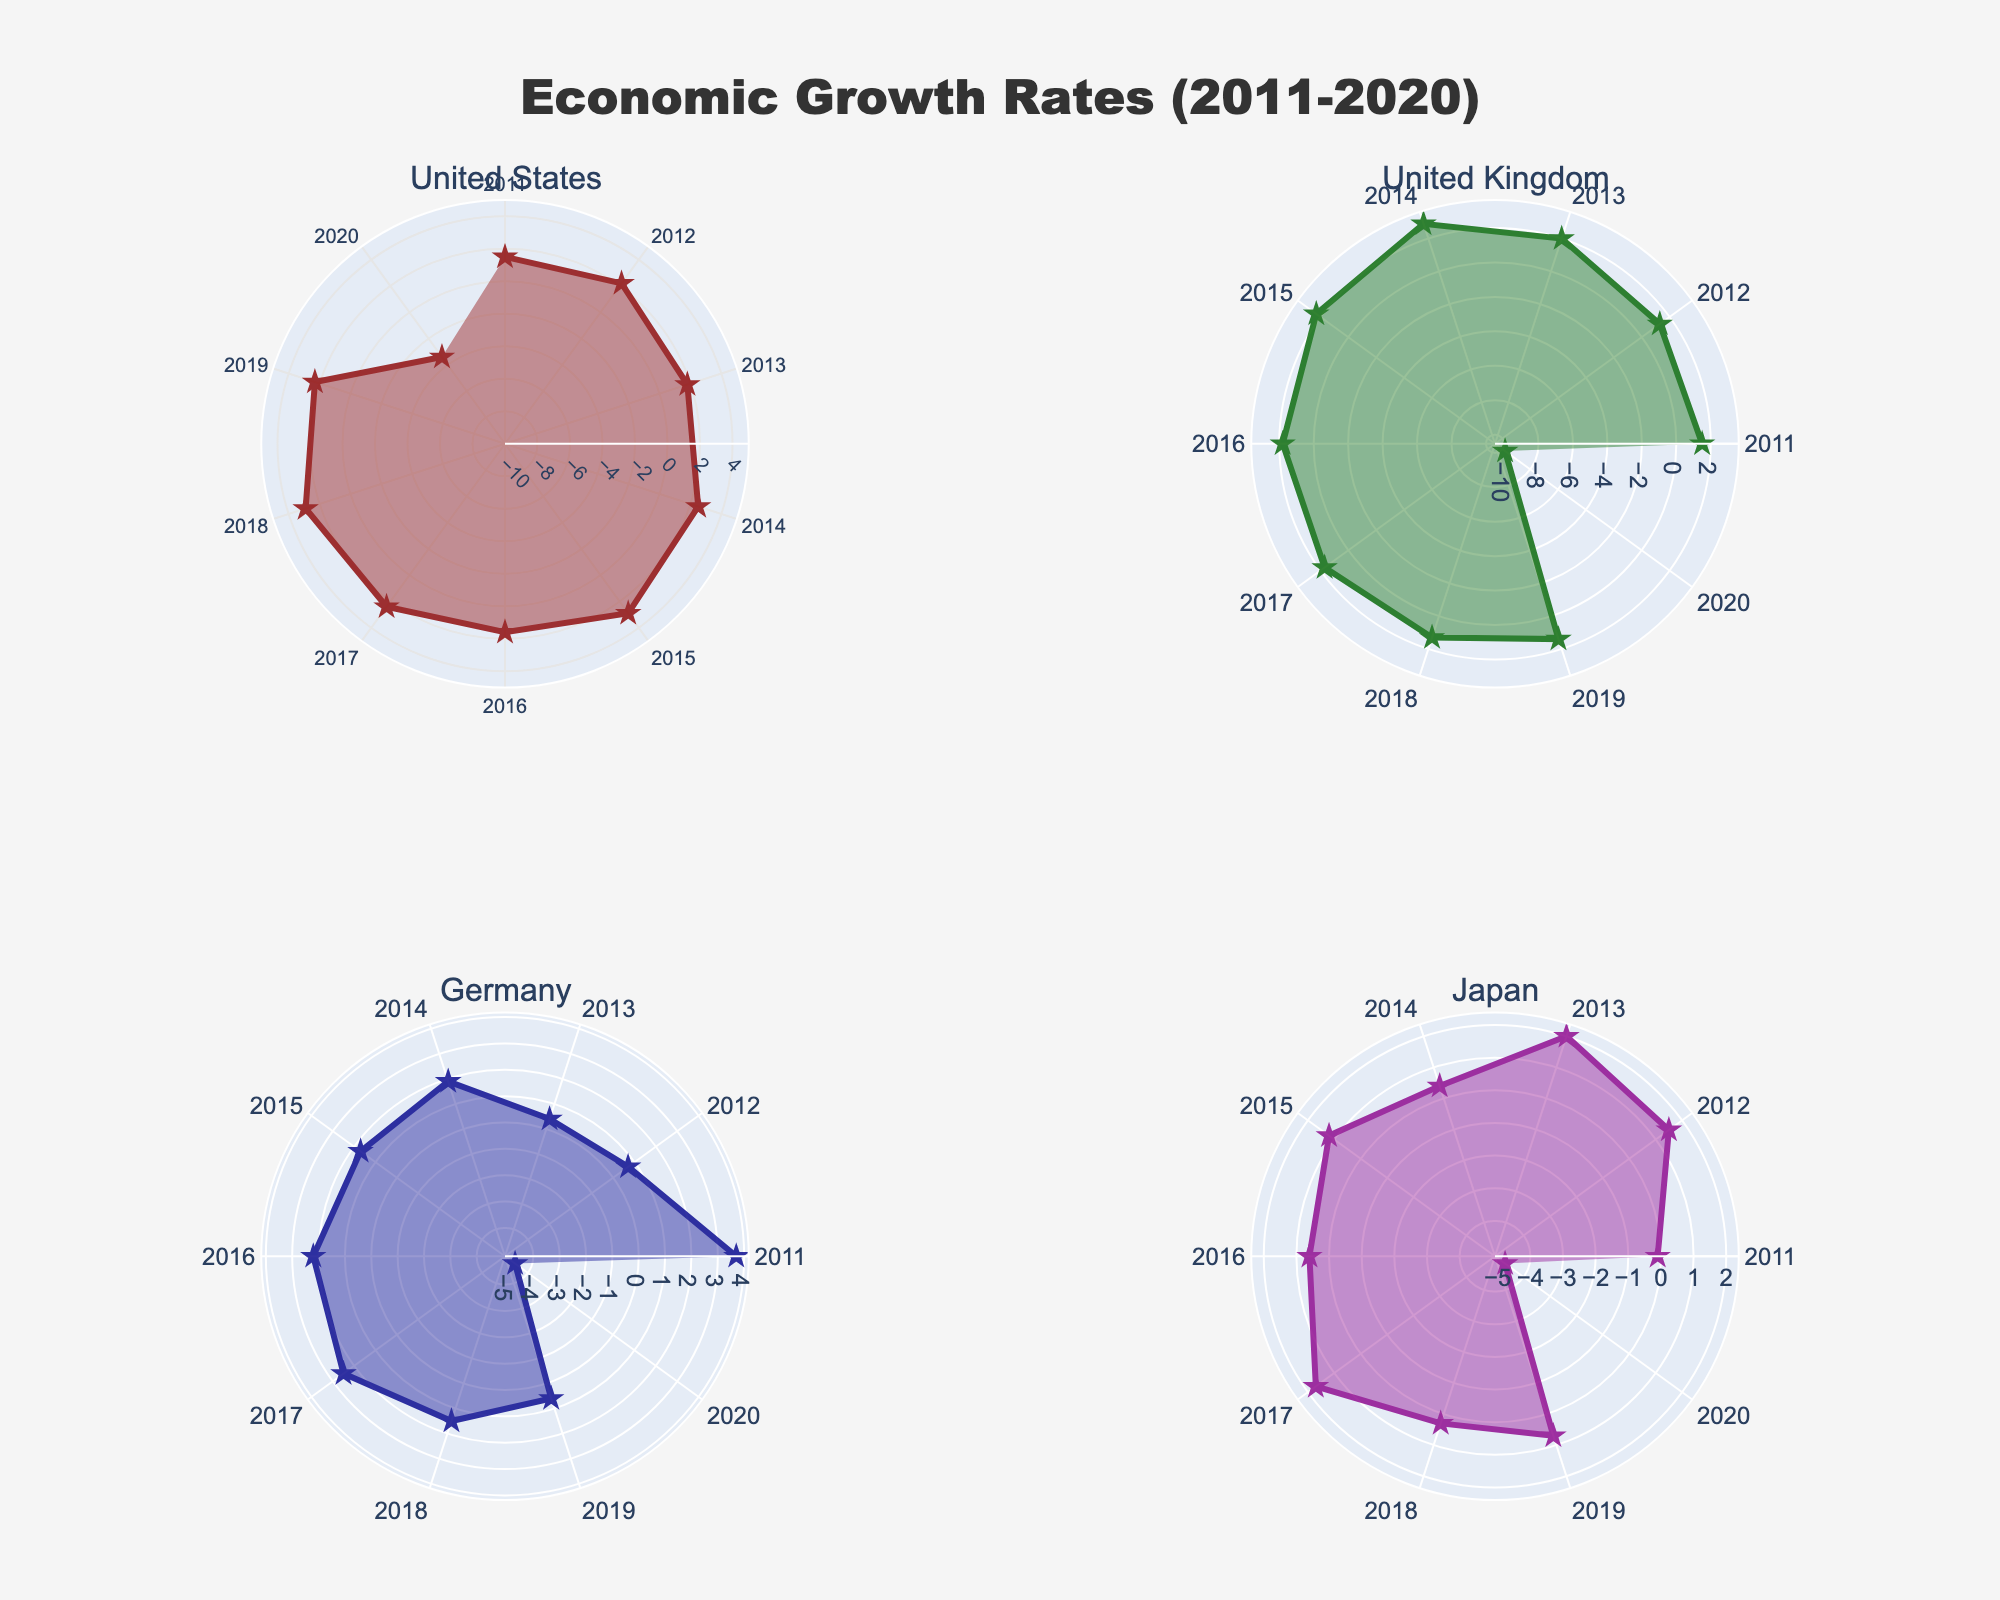What is the title of the figure? The title is prominently displayed at the top center of the figure. It reads, "Economic Growth Rates (2011-2020)."
Answer: Economic Growth Rates (2011-2020) Which country had the lowest GDP growth rate in 2020? By inspecting each subplot for the year 2020, we can see that the United Kingdom had the lowest GDP growth rate with -9.8%.
Answer: United Kingdom In which year did the United States experience its highest GDP growth rate? By looking at the United States subplot and comparing the values, 2015 and 2018 both had the highest rate of 2.9%.
Answer: 2015 and 2018 Which country had the most stable GDP growth rate over the last decade? Stability can be observed by the consistency of the curve. Japan shows a relatively stable curve compared with significant fluctuations in the other countries.
Answer: Japan How did Germany's GDP growth rate change from 2011 to 2020? From examining the Germany subplot, we see its GDP growth rate decreases from 3.7% in 2011 to -4.6% in 2020.
Answer: Decreased from 3.7% to -4.6% Which country showed a negative GDP growth rate at most instances over the last decade? By observing each subplot, Japan had the most instances with a negative GDP growth rate, especially in 2011 and 2020.
Answer: Japan Between 2013 to 2017, which country had the highest overall improvement in GDP growth rate? By comparing the changes in GDP growth rates between 2013 and 2017 for each country, Germany shows an improvement from 0.4% to 2.5%, which is the highest.
Answer: Germany Which years saw economic contraction (negative growth rate) for more than one country? In 2020, all countries show a negative GDP growth rate. Similarly, in 2011, Japan also shows a negative GDP growth rate.
Answer: 2020 and 2011 Out of all the countries, which had the most significant GDP growth dip from one year to the next? By analyzing the curves, the United Kingdom shows the most significant dip from 2.9% in 2014 to 1.8% in 2016.
Answer: United Kingdom, 2014 to 2016 